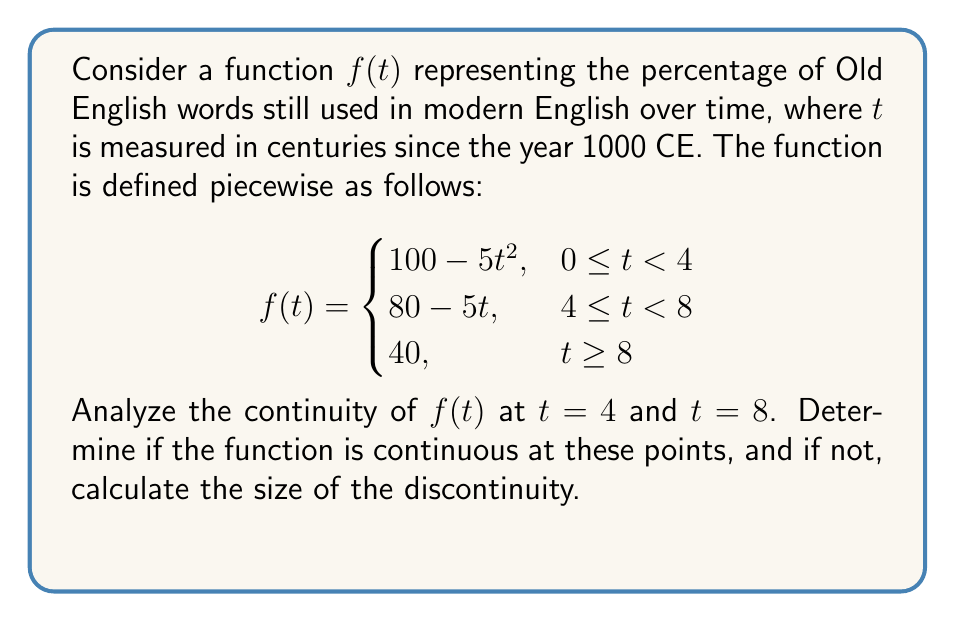What is the answer to this math problem? Let's analyze the continuity at $t = 4$ and $t = 8$ step by step:

1. Continuity at $t = 4$:
   a) Left-hand limit:
      $\lim_{t \to 4^-} f(t) = \lim_{t \to 4^-} (100 - 5t^2) = 100 - 5(4^2) = 20$
   b) Right-hand limit:
      $\lim_{t \to 4^+} f(t) = \lim_{t \to 4^+} (80 - 5t) = 80 - 5(4) = 60$
   c) Function value at $t = 4$:
      $f(4) = 80 - 5(4) = 60$

   The left-hand limit (20) does not equal the right-hand limit (60), so $f(t)$ is not continuous at $t = 4$.
   The size of the discontinuity is $60 - 20 = 40$.

2. Continuity at $t = 8$:
   a) Left-hand limit:
      $\lim_{t \to 8^-} f(t) = \lim_{t \to 8^-} (80 - 5t) = 80 - 5(8) = 40$
   b) Right-hand limit:
      $\lim_{t \to 8^+} f(t) = 40$
   c) Function value at $t = 8$:
      $f(8) = 40$

   The left-hand limit, right-hand limit, and function value are all equal to 40, so $f(t)$ is continuous at $t = 8$.

Therefore, $f(t)$ is discontinuous at $t = 4$ with a jump discontinuity of size 40, and continuous at $t = 8$.
Answer: Discontinuous at $t = 4$ with jump of 40; continuous at $t = 8$. 